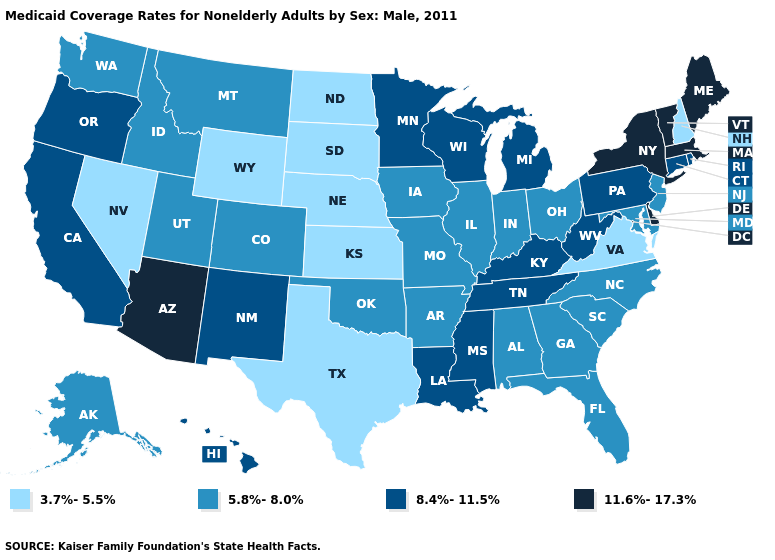Does Indiana have a lower value than Colorado?
Quick response, please. No. What is the lowest value in the USA?
Keep it brief. 3.7%-5.5%. Name the states that have a value in the range 3.7%-5.5%?
Quick response, please. Kansas, Nebraska, Nevada, New Hampshire, North Dakota, South Dakota, Texas, Virginia, Wyoming. What is the value of Idaho?
Write a very short answer. 5.8%-8.0%. Name the states that have a value in the range 3.7%-5.5%?
Be succinct. Kansas, Nebraska, Nevada, New Hampshire, North Dakota, South Dakota, Texas, Virginia, Wyoming. What is the value of California?
Answer briefly. 8.4%-11.5%. What is the lowest value in the USA?
Give a very brief answer. 3.7%-5.5%. Name the states that have a value in the range 8.4%-11.5%?
Short answer required. California, Connecticut, Hawaii, Kentucky, Louisiana, Michigan, Minnesota, Mississippi, New Mexico, Oregon, Pennsylvania, Rhode Island, Tennessee, West Virginia, Wisconsin. Among the states that border Oklahoma , does Missouri have the lowest value?
Give a very brief answer. No. What is the value of Montana?
Concise answer only. 5.8%-8.0%. What is the value of Oklahoma?
Short answer required. 5.8%-8.0%. What is the value of Utah?
Concise answer only. 5.8%-8.0%. Name the states that have a value in the range 3.7%-5.5%?
Keep it brief. Kansas, Nebraska, Nevada, New Hampshire, North Dakota, South Dakota, Texas, Virginia, Wyoming. Name the states that have a value in the range 5.8%-8.0%?
Quick response, please. Alabama, Alaska, Arkansas, Colorado, Florida, Georgia, Idaho, Illinois, Indiana, Iowa, Maryland, Missouri, Montana, New Jersey, North Carolina, Ohio, Oklahoma, South Carolina, Utah, Washington. Which states have the lowest value in the West?
Concise answer only. Nevada, Wyoming. 